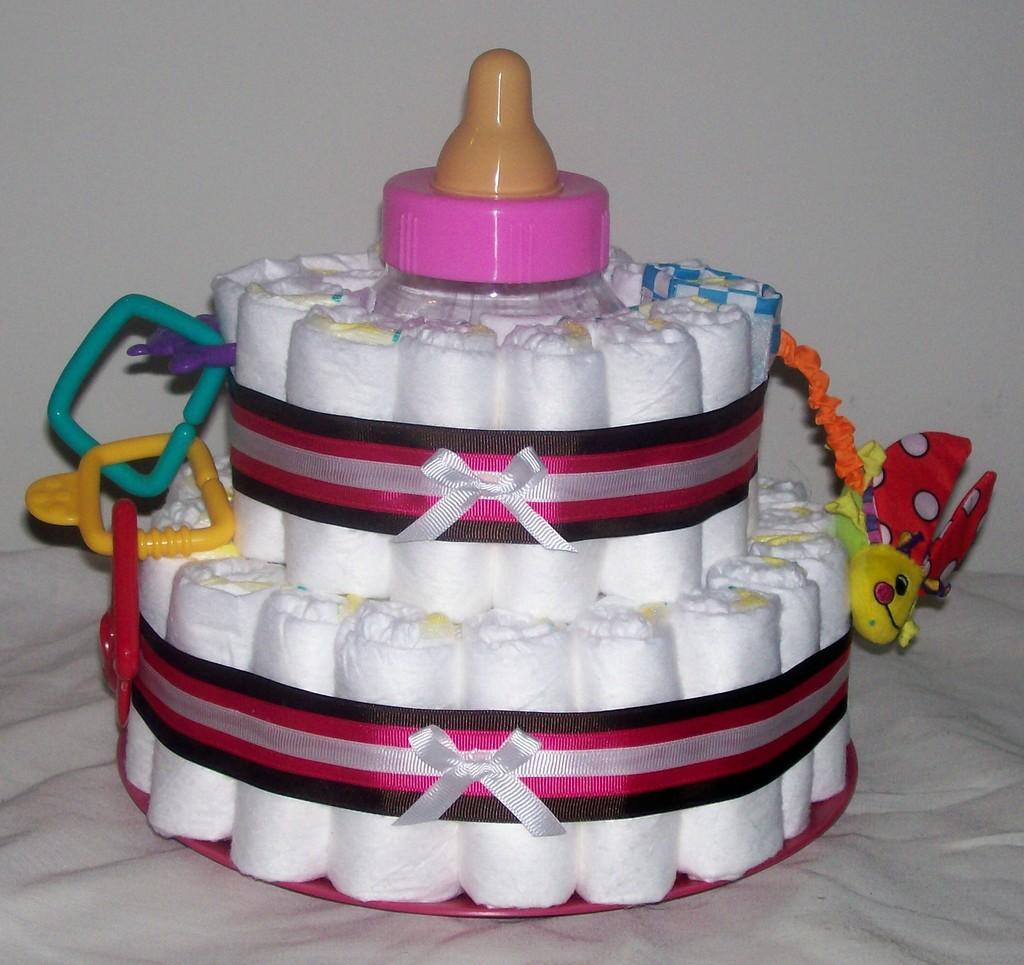Could you give a brief overview of what you see in this image? In this image there is a cake which is on the surface which is white in colour. 